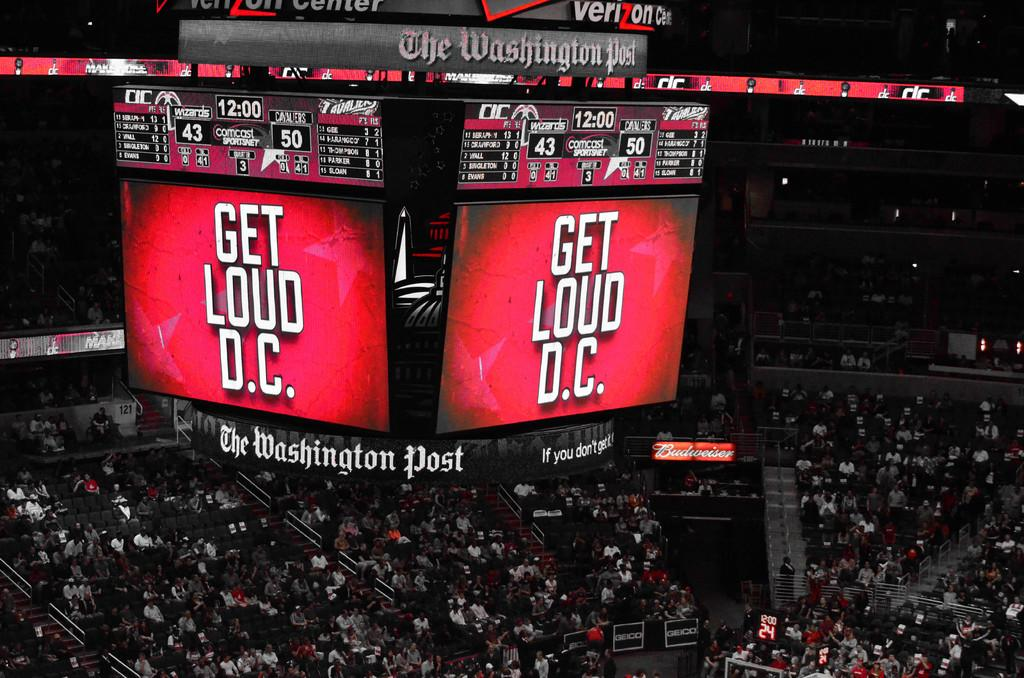<image>
Summarize the visual content of the image. A Jumbotron in an arena that says Get Loud DC. 